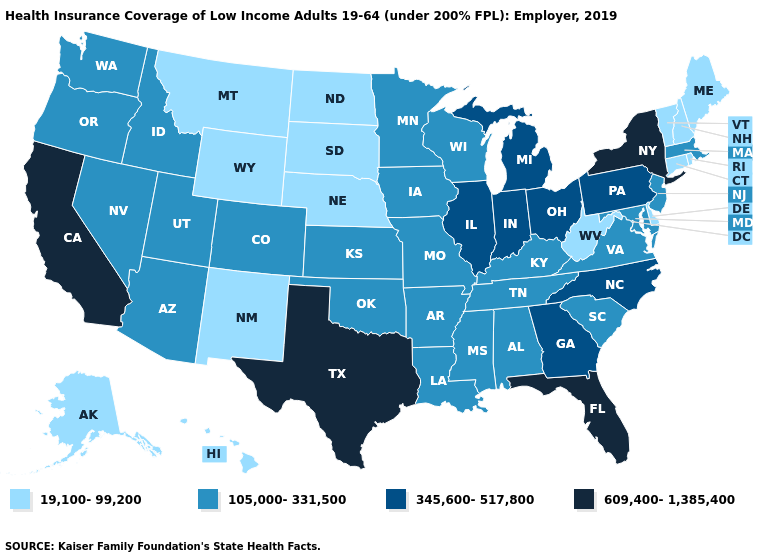What is the highest value in the USA?
Quick response, please. 609,400-1,385,400. Does the map have missing data?
Write a very short answer. No. What is the value of Utah?
Answer briefly. 105,000-331,500. Name the states that have a value in the range 19,100-99,200?
Be succinct. Alaska, Connecticut, Delaware, Hawaii, Maine, Montana, Nebraska, New Hampshire, New Mexico, North Dakota, Rhode Island, South Dakota, Vermont, West Virginia, Wyoming. What is the value of Delaware?
Write a very short answer. 19,100-99,200. Name the states that have a value in the range 105,000-331,500?
Write a very short answer. Alabama, Arizona, Arkansas, Colorado, Idaho, Iowa, Kansas, Kentucky, Louisiana, Maryland, Massachusetts, Minnesota, Mississippi, Missouri, Nevada, New Jersey, Oklahoma, Oregon, South Carolina, Tennessee, Utah, Virginia, Washington, Wisconsin. Name the states that have a value in the range 105,000-331,500?
Give a very brief answer. Alabama, Arizona, Arkansas, Colorado, Idaho, Iowa, Kansas, Kentucky, Louisiana, Maryland, Massachusetts, Minnesota, Mississippi, Missouri, Nevada, New Jersey, Oklahoma, Oregon, South Carolina, Tennessee, Utah, Virginia, Washington, Wisconsin. What is the value of Nevada?
Keep it brief. 105,000-331,500. What is the value of Alabama?
Give a very brief answer. 105,000-331,500. What is the value of New Hampshire?
Quick response, please. 19,100-99,200. What is the highest value in the South ?
Write a very short answer. 609,400-1,385,400. What is the value of Kentucky?
Keep it brief. 105,000-331,500. Which states have the lowest value in the USA?
Be succinct. Alaska, Connecticut, Delaware, Hawaii, Maine, Montana, Nebraska, New Hampshire, New Mexico, North Dakota, Rhode Island, South Dakota, Vermont, West Virginia, Wyoming. Name the states that have a value in the range 609,400-1,385,400?
Quick response, please. California, Florida, New York, Texas. What is the value of Nevada?
Write a very short answer. 105,000-331,500. 